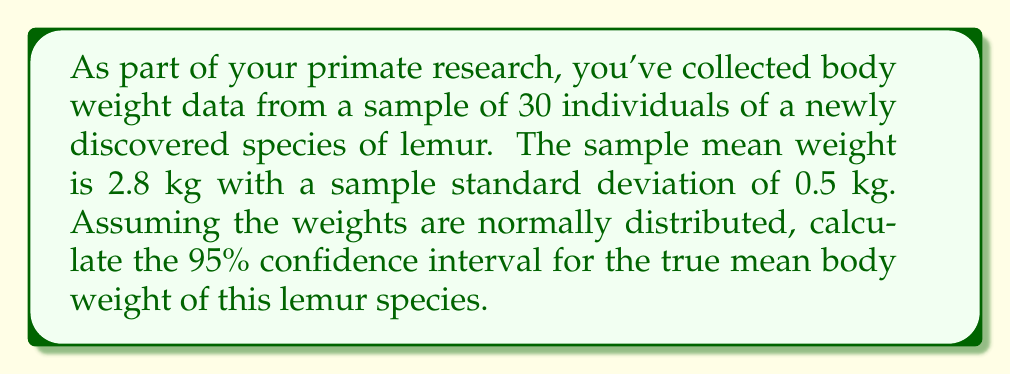Show me your answer to this math problem. To calculate the confidence interval, we'll follow these steps:

1) The formula for the confidence interval of a mean is:

   $$ \bar{x} \pm t_{\alpha/2, n-1} \cdot \frac{s}{\sqrt{n}} $$

   Where:
   $\bar{x}$ is the sample mean
   $t_{\alpha/2, n-1}$ is the t-value for the desired confidence level with n-1 degrees of freedom
   $s$ is the sample standard deviation
   $n$ is the sample size

2) We know:
   $\bar{x} = 2.8$ kg
   $s = 0.5$ kg
   $n = 30$
   Confidence level = 95% (so $\alpha = 0.05$)

3) For a 95% confidence interval with 29 degrees of freedom (n-1 = 30-1 = 29), the t-value is approximately 2.045. (This can be found in a t-table or using statistical software)

4) Now we can plug these values into our formula:

   $$ 2.8 \pm 2.045 \cdot \frac{0.5}{\sqrt{30}} $$

5) Simplify:
   $$ 2.8 \pm 2.045 \cdot \frac{0.5}{5.477} $$
   $$ 2.8 \pm 2.045 \cdot 0.0913 $$
   $$ 2.8 \pm 0.1867 $$

6) Therefore, the confidence interval is:
   $$ (2.8 - 0.1867, 2.8 + 0.1867) $$
   $$ (2.6133, 2.9867) $$
Answer: The 95% confidence interval for the true mean body weight of the lemur species is (2.61 kg, 2.99 kg). 